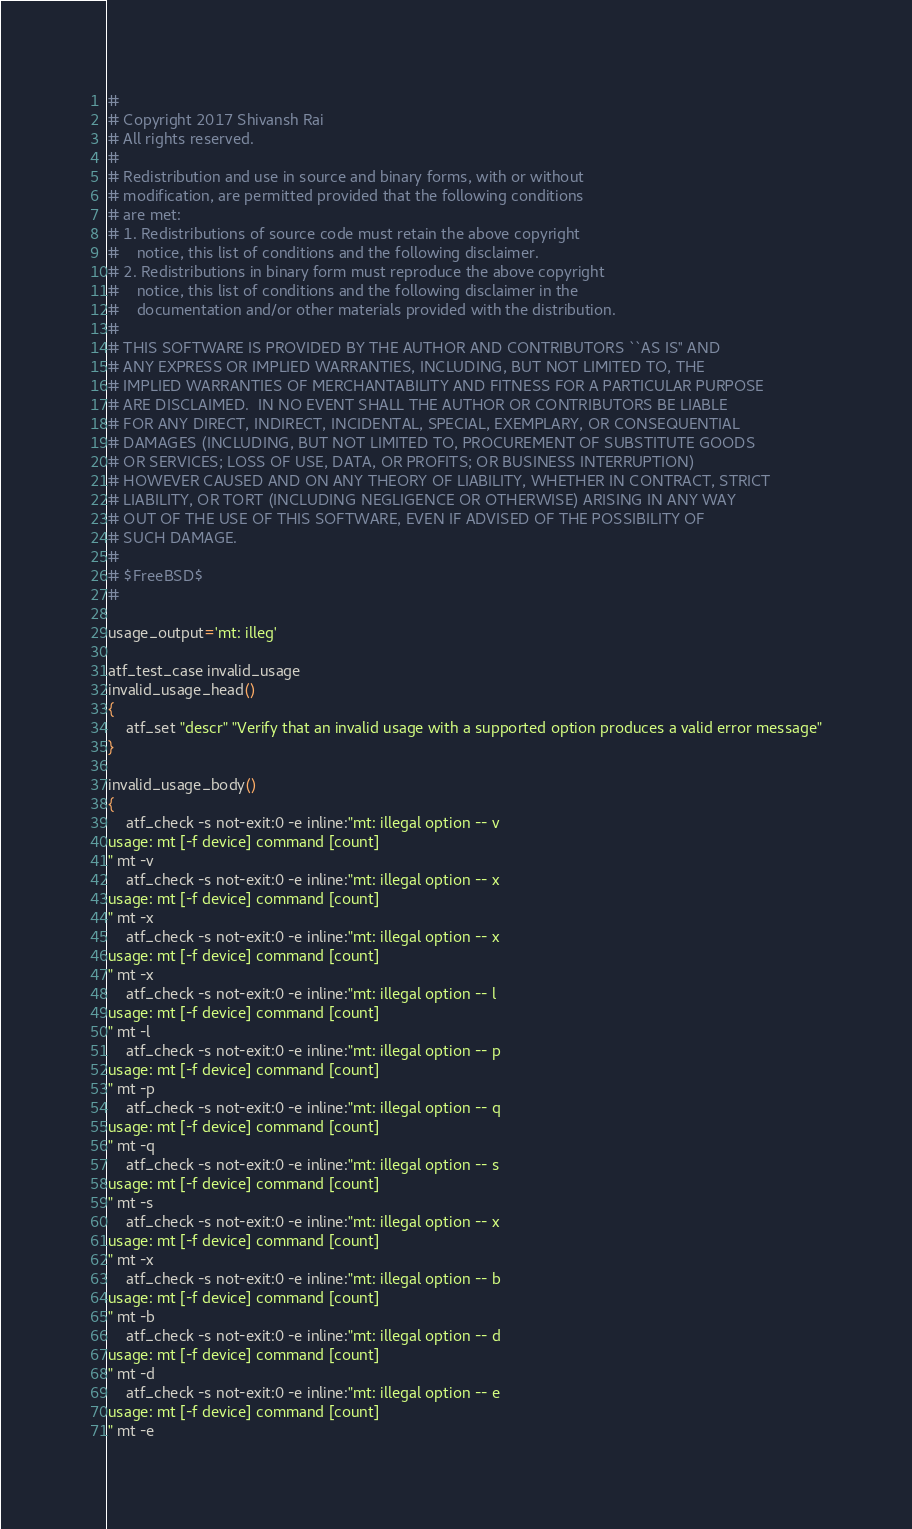Convert code to text. <code><loc_0><loc_0><loc_500><loc_500><_Bash_>#
# Copyright 2017 Shivansh Rai
# All rights reserved.
#
# Redistribution and use in source and binary forms, with or without
# modification, are permitted provided that the following conditions
# are met:
# 1. Redistributions of source code must retain the above copyright
#    notice, this list of conditions and the following disclaimer.
# 2. Redistributions in binary form must reproduce the above copyright
#    notice, this list of conditions and the following disclaimer in the
#    documentation and/or other materials provided with the distribution.
#
# THIS SOFTWARE IS PROVIDED BY THE AUTHOR AND CONTRIBUTORS ``AS IS'' AND
# ANY EXPRESS OR IMPLIED WARRANTIES, INCLUDING, BUT NOT LIMITED TO, THE
# IMPLIED WARRANTIES OF MERCHANTABILITY AND FITNESS FOR A PARTICULAR PURPOSE
# ARE DISCLAIMED.  IN NO EVENT SHALL THE AUTHOR OR CONTRIBUTORS BE LIABLE
# FOR ANY DIRECT, INDIRECT, INCIDENTAL, SPECIAL, EXEMPLARY, OR CONSEQUENTIAL
# DAMAGES (INCLUDING, BUT NOT LIMITED TO, PROCUREMENT OF SUBSTITUTE GOODS
# OR SERVICES; LOSS OF USE, DATA, OR PROFITS; OR BUSINESS INTERRUPTION)
# HOWEVER CAUSED AND ON ANY THEORY OF LIABILITY, WHETHER IN CONTRACT, STRICT
# LIABILITY, OR TORT (INCLUDING NEGLIGENCE OR OTHERWISE) ARISING IN ANY WAY
# OUT OF THE USE OF THIS SOFTWARE, EVEN IF ADVISED OF THE POSSIBILITY OF
# SUCH DAMAGE.
#
# $FreeBSD$
#

usage_output='mt: illeg'

atf_test_case invalid_usage
invalid_usage_head()
{
	atf_set "descr" "Verify that an invalid usage with a supported option produces a valid error message"
}

invalid_usage_body()
{
	atf_check -s not-exit:0 -e inline:"mt: illegal option -- v
usage: mt [-f device] command [count]
" mt -v
	atf_check -s not-exit:0 -e inline:"mt: illegal option -- x
usage: mt [-f device] command [count]
" mt -x
	atf_check -s not-exit:0 -e inline:"mt: illegal option -- x
usage: mt [-f device] command [count]
" mt -x
	atf_check -s not-exit:0 -e inline:"mt: illegal option -- l
usage: mt [-f device] command [count]
" mt -l
	atf_check -s not-exit:0 -e inline:"mt: illegal option -- p
usage: mt [-f device] command [count]
" mt -p
	atf_check -s not-exit:0 -e inline:"mt: illegal option -- q
usage: mt [-f device] command [count]
" mt -q
	atf_check -s not-exit:0 -e inline:"mt: illegal option -- s
usage: mt [-f device] command [count]
" mt -s
	atf_check -s not-exit:0 -e inline:"mt: illegal option -- x
usage: mt [-f device] command [count]
" mt -x
	atf_check -s not-exit:0 -e inline:"mt: illegal option -- b
usage: mt [-f device] command [count]
" mt -b
	atf_check -s not-exit:0 -e inline:"mt: illegal option -- d
usage: mt [-f device] command [count]
" mt -d
	atf_check -s not-exit:0 -e inline:"mt: illegal option -- e
usage: mt [-f device] command [count]
" mt -e</code> 